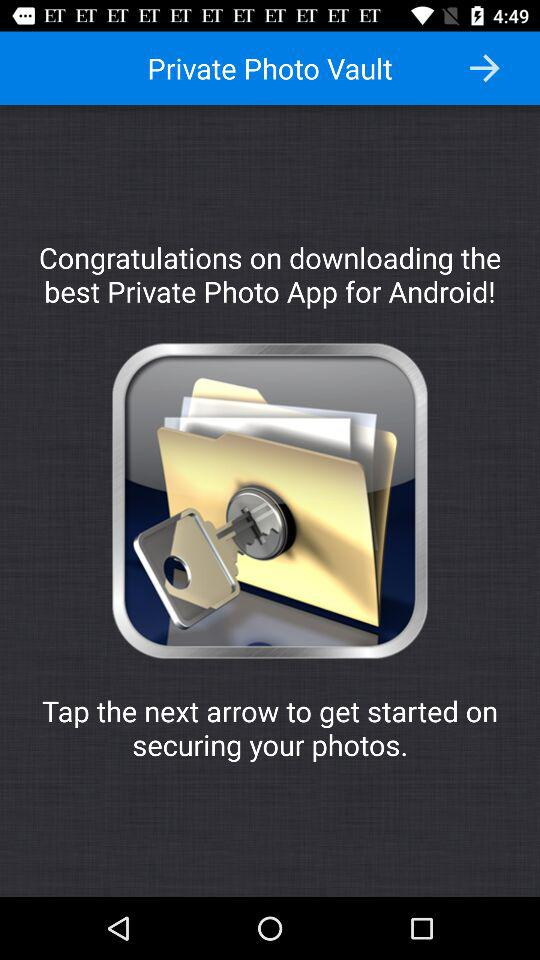What is the application name? The application name is "Private Photo Vault". 